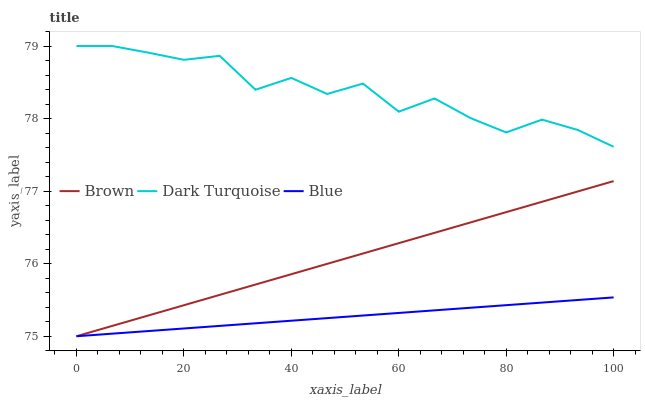Does Brown have the minimum area under the curve?
Answer yes or no. No. Does Brown have the maximum area under the curve?
Answer yes or no. No. Is Dark Turquoise the smoothest?
Answer yes or no. No. Is Brown the roughest?
Answer yes or no. No. Does Dark Turquoise have the lowest value?
Answer yes or no. No. Does Brown have the highest value?
Answer yes or no. No. Is Brown less than Dark Turquoise?
Answer yes or no. Yes. Is Dark Turquoise greater than Brown?
Answer yes or no. Yes. Does Brown intersect Dark Turquoise?
Answer yes or no. No. 